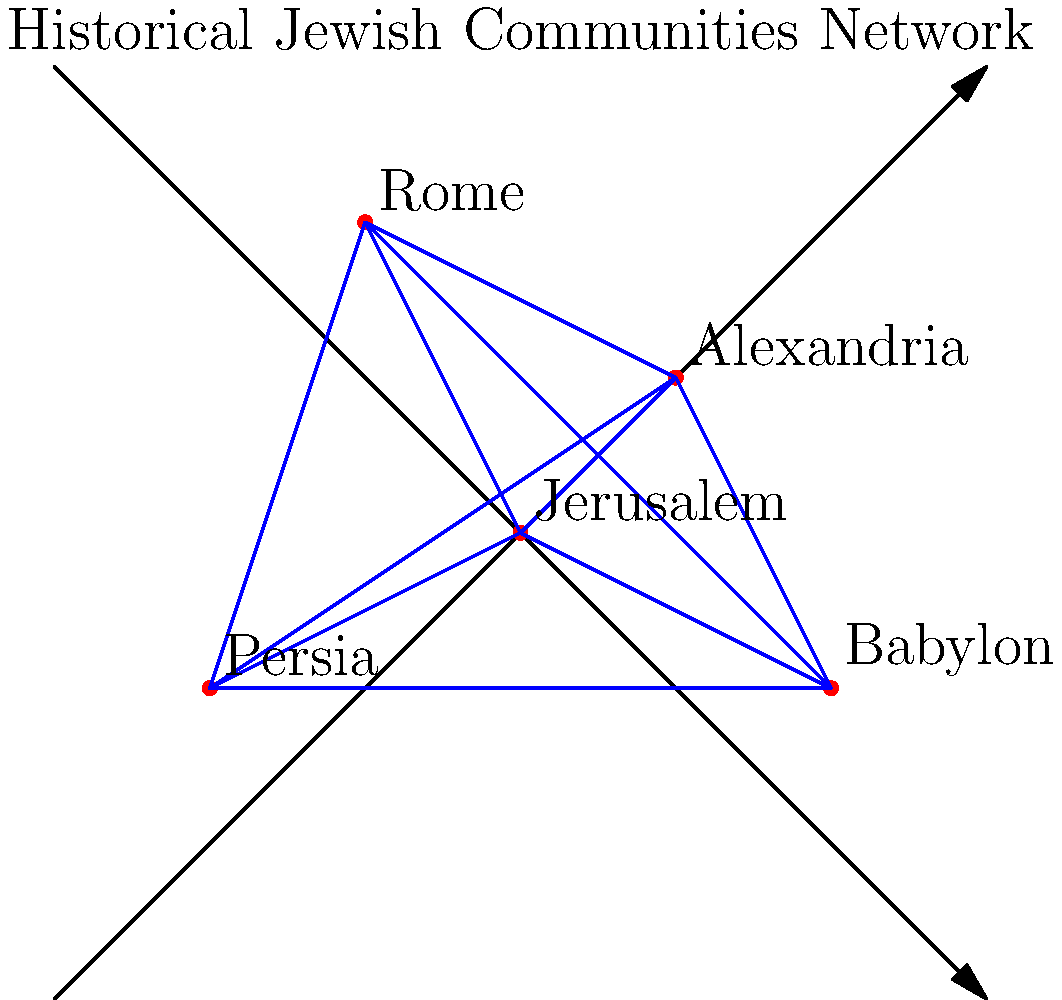Based on the historical map of Jewish communities shown above, which city appears to be the most central node in the network of connections, and how might this centrality have influenced the spread and development of Jewish practices across different regions? To answer this question, we need to analyze the map and consider the historical context:

1. Observe the map: The diagram shows five major Jewish communities connected by a network of lines.

2. Identify the central node: Jerusalem appears to be at the center of the network, with direct connections to all other communities.

3. Consider historical context: Jerusalem was the location of the Temple, the center of Jewish worship and pilgrimage.

4. Analyze the implications of centrality:
   a) Communication hub: Ideas and practices could easily spread from Jerusalem to other communities.
   b) Religious authority: Decisions made in Jerusalem would likely influence other communities.
   c) Pilgrimage center: Regular visits to Jerusalem would reinforce common practices and unity.

5. Consider the spread of practices:
   a) Standardization: Central authority could lead to more uniform practices across communities.
   b) Adaptation: As practices spread, they might be adapted to local contexts in each community.

6. Reflect on modern applications:
   a) Understanding historical networks can inform current efforts to maintain Jewish unity.
   b) Recognizing the historical role of Jerusalem can guide contemporary discussions on its significance.
Answer: Jerusalem; central location facilitated spread and standardization of practices while allowing for regional adaptations. 